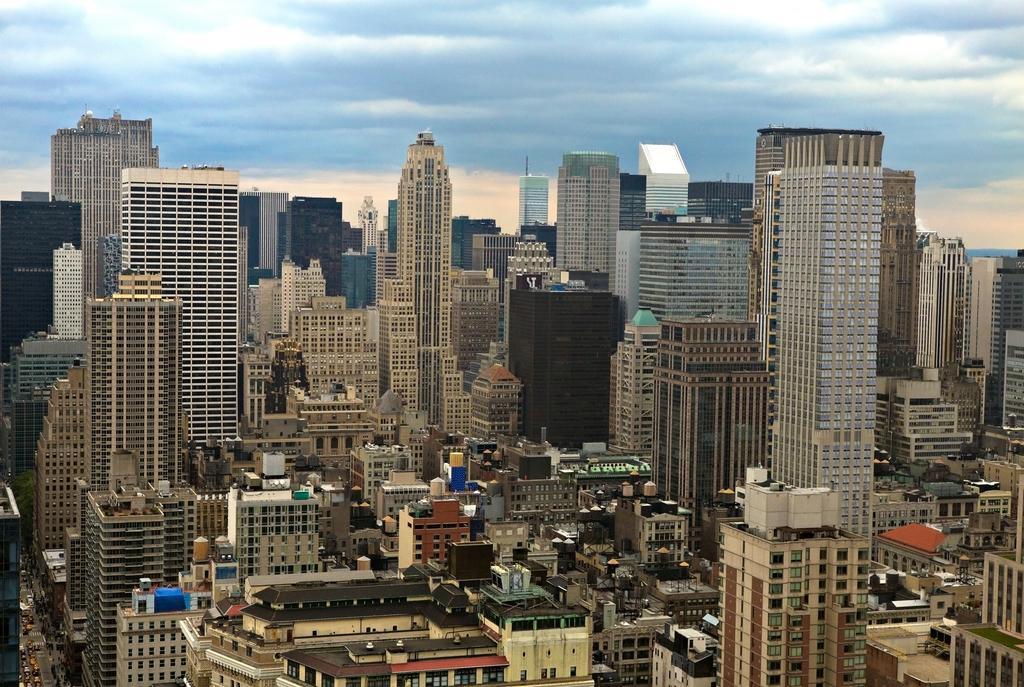Please provide a concise description of this image. In this image we can see many buildings. We can also see the vehicles passing on the road on the left. At the top there is sky with the clouds. 